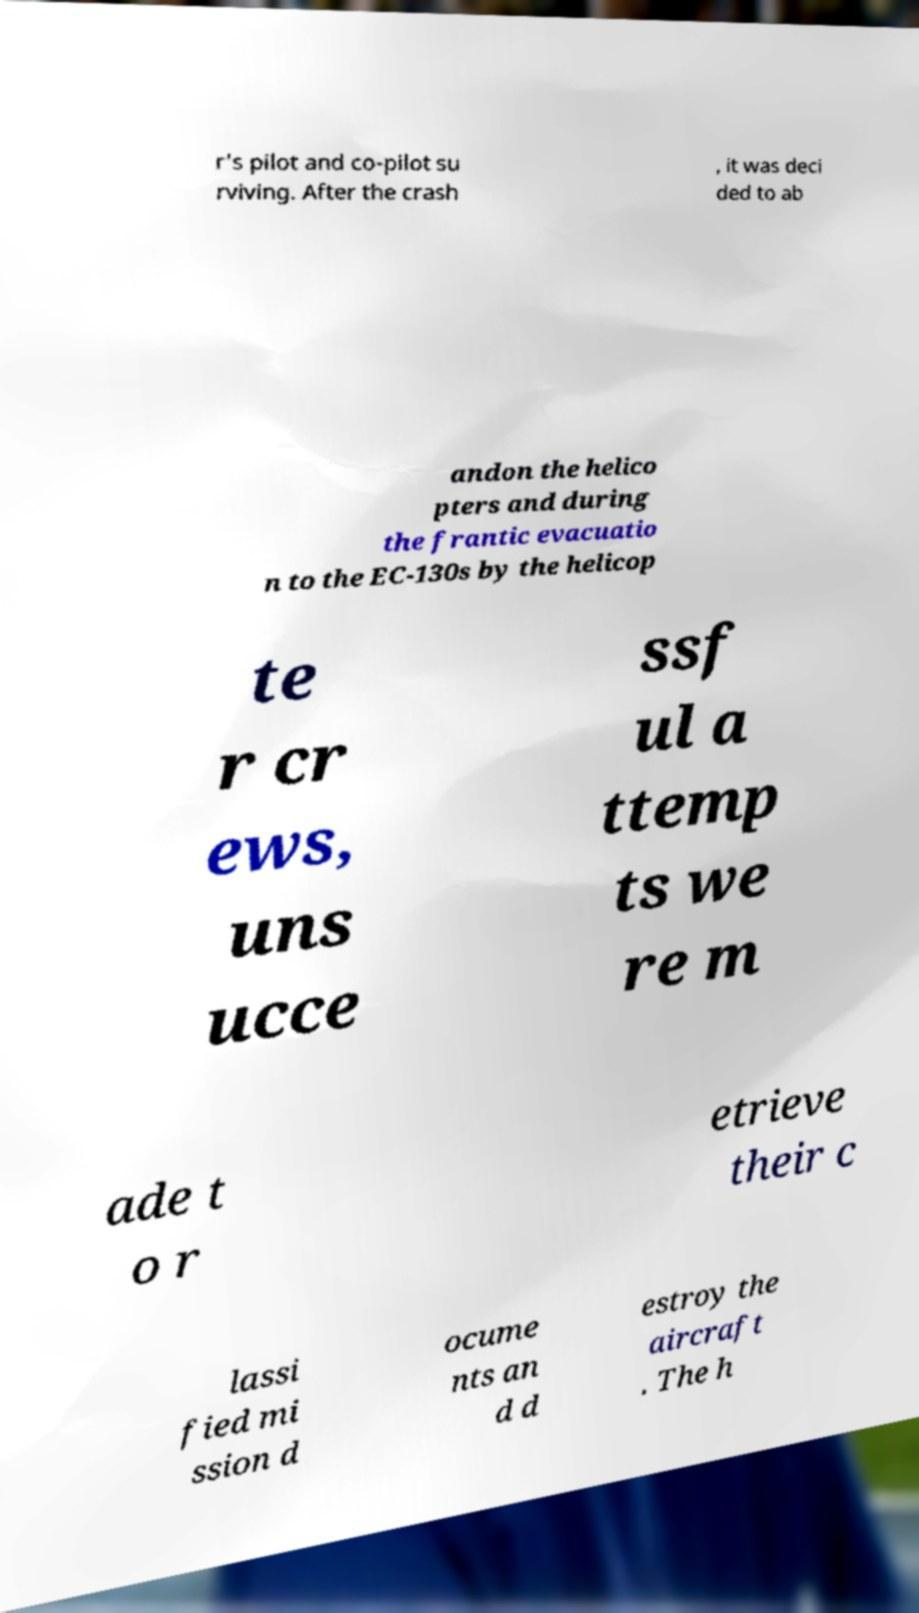Please identify and transcribe the text found in this image. r's pilot and co-pilot su rviving. After the crash , it was deci ded to ab andon the helico pters and during the frantic evacuatio n to the EC-130s by the helicop te r cr ews, uns ucce ssf ul a ttemp ts we re m ade t o r etrieve their c lassi fied mi ssion d ocume nts an d d estroy the aircraft . The h 